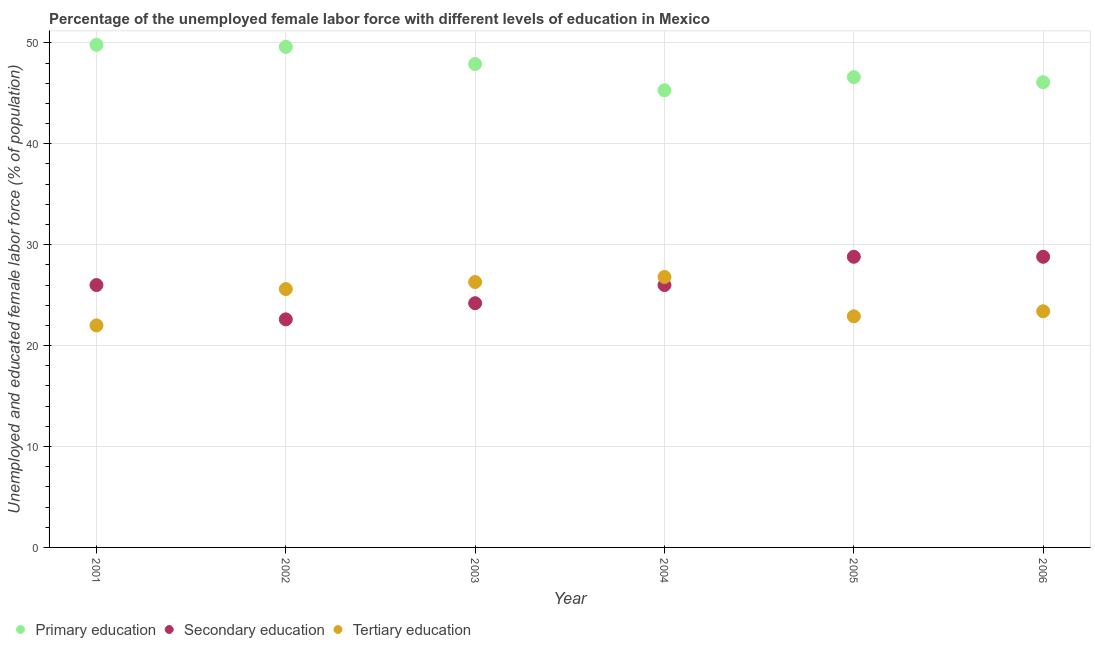What is the percentage of female labor force who received tertiary education in 2005?
Provide a succinct answer. 22.9. Across all years, what is the maximum percentage of female labor force who received secondary education?
Offer a very short reply. 28.8. In which year was the percentage of female labor force who received primary education minimum?
Give a very brief answer. 2004. What is the total percentage of female labor force who received primary education in the graph?
Ensure brevity in your answer.  285.3. What is the difference between the percentage of female labor force who received tertiary education in 2003 and that in 2005?
Your answer should be very brief. 3.4. What is the difference between the percentage of female labor force who received primary education in 2003 and the percentage of female labor force who received tertiary education in 2006?
Offer a terse response. 24.5. What is the average percentage of female labor force who received secondary education per year?
Keep it short and to the point. 26.07. In the year 2004, what is the difference between the percentage of female labor force who received primary education and percentage of female labor force who received secondary education?
Ensure brevity in your answer.  19.3. In how many years, is the percentage of female labor force who received tertiary education greater than 2 %?
Make the answer very short. 6. What is the ratio of the percentage of female labor force who received primary education in 2004 to that in 2005?
Offer a terse response. 0.97. Is the difference between the percentage of female labor force who received secondary education in 2003 and 2006 greater than the difference between the percentage of female labor force who received primary education in 2003 and 2006?
Your answer should be very brief. No. What is the difference between the highest and the lowest percentage of female labor force who received tertiary education?
Ensure brevity in your answer.  4.8. In how many years, is the percentage of female labor force who received secondary education greater than the average percentage of female labor force who received secondary education taken over all years?
Provide a succinct answer. 2. Is the sum of the percentage of female labor force who received tertiary education in 2003 and 2005 greater than the maximum percentage of female labor force who received primary education across all years?
Give a very brief answer. No. Is it the case that in every year, the sum of the percentage of female labor force who received primary education and percentage of female labor force who received secondary education is greater than the percentage of female labor force who received tertiary education?
Provide a short and direct response. Yes. How many dotlines are there?
Keep it short and to the point. 3. How many years are there in the graph?
Your answer should be very brief. 6. Where does the legend appear in the graph?
Offer a terse response. Bottom left. How are the legend labels stacked?
Offer a very short reply. Horizontal. What is the title of the graph?
Your response must be concise. Percentage of the unemployed female labor force with different levels of education in Mexico. Does "Primary" appear as one of the legend labels in the graph?
Your response must be concise. No. What is the label or title of the Y-axis?
Your response must be concise. Unemployed and educated female labor force (% of population). What is the Unemployed and educated female labor force (% of population) of Primary education in 2001?
Give a very brief answer. 49.8. What is the Unemployed and educated female labor force (% of population) of Secondary education in 2001?
Your response must be concise. 26. What is the Unemployed and educated female labor force (% of population) in Primary education in 2002?
Offer a very short reply. 49.6. What is the Unemployed and educated female labor force (% of population) of Secondary education in 2002?
Offer a terse response. 22.6. What is the Unemployed and educated female labor force (% of population) of Tertiary education in 2002?
Provide a succinct answer. 25.6. What is the Unemployed and educated female labor force (% of population) of Primary education in 2003?
Give a very brief answer. 47.9. What is the Unemployed and educated female labor force (% of population) in Secondary education in 2003?
Keep it short and to the point. 24.2. What is the Unemployed and educated female labor force (% of population) of Tertiary education in 2003?
Your answer should be compact. 26.3. What is the Unemployed and educated female labor force (% of population) in Primary education in 2004?
Provide a succinct answer. 45.3. What is the Unemployed and educated female labor force (% of population) of Tertiary education in 2004?
Offer a terse response. 26.8. What is the Unemployed and educated female labor force (% of population) of Primary education in 2005?
Provide a succinct answer. 46.6. What is the Unemployed and educated female labor force (% of population) in Secondary education in 2005?
Give a very brief answer. 28.8. What is the Unemployed and educated female labor force (% of population) in Tertiary education in 2005?
Offer a very short reply. 22.9. What is the Unemployed and educated female labor force (% of population) in Primary education in 2006?
Provide a short and direct response. 46.1. What is the Unemployed and educated female labor force (% of population) of Secondary education in 2006?
Your answer should be compact. 28.8. What is the Unemployed and educated female labor force (% of population) in Tertiary education in 2006?
Make the answer very short. 23.4. Across all years, what is the maximum Unemployed and educated female labor force (% of population) in Primary education?
Provide a short and direct response. 49.8. Across all years, what is the maximum Unemployed and educated female labor force (% of population) of Secondary education?
Make the answer very short. 28.8. Across all years, what is the maximum Unemployed and educated female labor force (% of population) in Tertiary education?
Offer a terse response. 26.8. Across all years, what is the minimum Unemployed and educated female labor force (% of population) of Primary education?
Offer a terse response. 45.3. Across all years, what is the minimum Unemployed and educated female labor force (% of population) of Secondary education?
Your answer should be compact. 22.6. What is the total Unemployed and educated female labor force (% of population) of Primary education in the graph?
Make the answer very short. 285.3. What is the total Unemployed and educated female labor force (% of population) of Secondary education in the graph?
Provide a short and direct response. 156.4. What is the total Unemployed and educated female labor force (% of population) of Tertiary education in the graph?
Make the answer very short. 147. What is the difference between the Unemployed and educated female labor force (% of population) of Secondary education in 2001 and that in 2002?
Offer a terse response. 3.4. What is the difference between the Unemployed and educated female labor force (% of population) of Primary education in 2001 and that in 2003?
Provide a succinct answer. 1.9. What is the difference between the Unemployed and educated female labor force (% of population) in Secondary education in 2001 and that in 2003?
Ensure brevity in your answer.  1.8. What is the difference between the Unemployed and educated female labor force (% of population) of Tertiary education in 2001 and that in 2003?
Your answer should be very brief. -4.3. What is the difference between the Unemployed and educated female labor force (% of population) of Primary education in 2001 and that in 2004?
Provide a short and direct response. 4.5. What is the difference between the Unemployed and educated female labor force (% of population) of Secondary education in 2001 and that in 2004?
Make the answer very short. 0. What is the difference between the Unemployed and educated female labor force (% of population) of Primary education in 2001 and that in 2005?
Your answer should be very brief. 3.2. What is the difference between the Unemployed and educated female labor force (% of population) in Secondary education in 2001 and that in 2005?
Offer a very short reply. -2.8. What is the difference between the Unemployed and educated female labor force (% of population) of Secondary education in 2001 and that in 2006?
Provide a succinct answer. -2.8. What is the difference between the Unemployed and educated female labor force (% of population) of Tertiary education in 2001 and that in 2006?
Your response must be concise. -1.4. What is the difference between the Unemployed and educated female labor force (% of population) in Primary education in 2002 and that in 2004?
Your answer should be very brief. 4.3. What is the difference between the Unemployed and educated female labor force (% of population) in Secondary education in 2002 and that in 2004?
Offer a very short reply. -3.4. What is the difference between the Unemployed and educated female labor force (% of population) in Tertiary education in 2002 and that in 2004?
Make the answer very short. -1.2. What is the difference between the Unemployed and educated female labor force (% of population) in Primary education in 2002 and that in 2005?
Keep it short and to the point. 3. What is the difference between the Unemployed and educated female labor force (% of population) of Tertiary education in 2002 and that in 2005?
Your answer should be very brief. 2.7. What is the difference between the Unemployed and educated female labor force (% of population) in Primary education in 2003 and that in 2004?
Provide a short and direct response. 2.6. What is the difference between the Unemployed and educated female labor force (% of population) of Primary education in 2003 and that in 2005?
Offer a terse response. 1.3. What is the difference between the Unemployed and educated female labor force (% of population) in Secondary education in 2003 and that in 2005?
Keep it short and to the point. -4.6. What is the difference between the Unemployed and educated female labor force (% of population) in Tertiary education in 2003 and that in 2005?
Your answer should be very brief. 3.4. What is the difference between the Unemployed and educated female labor force (% of population) in Secondary education in 2003 and that in 2006?
Give a very brief answer. -4.6. What is the difference between the Unemployed and educated female labor force (% of population) of Primary education in 2004 and that in 2006?
Keep it short and to the point. -0.8. What is the difference between the Unemployed and educated female labor force (% of population) in Tertiary education in 2004 and that in 2006?
Your response must be concise. 3.4. What is the difference between the Unemployed and educated female labor force (% of population) of Secondary education in 2005 and that in 2006?
Your answer should be very brief. 0. What is the difference between the Unemployed and educated female labor force (% of population) of Tertiary education in 2005 and that in 2006?
Your response must be concise. -0.5. What is the difference between the Unemployed and educated female labor force (% of population) of Primary education in 2001 and the Unemployed and educated female labor force (% of population) of Secondary education in 2002?
Give a very brief answer. 27.2. What is the difference between the Unemployed and educated female labor force (% of population) in Primary education in 2001 and the Unemployed and educated female labor force (% of population) in Tertiary education in 2002?
Your answer should be compact. 24.2. What is the difference between the Unemployed and educated female labor force (% of population) in Primary education in 2001 and the Unemployed and educated female labor force (% of population) in Secondary education in 2003?
Provide a succinct answer. 25.6. What is the difference between the Unemployed and educated female labor force (% of population) of Primary education in 2001 and the Unemployed and educated female labor force (% of population) of Secondary education in 2004?
Give a very brief answer. 23.8. What is the difference between the Unemployed and educated female labor force (% of population) in Secondary education in 2001 and the Unemployed and educated female labor force (% of population) in Tertiary education in 2004?
Your answer should be compact. -0.8. What is the difference between the Unemployed and educated female labor force (% of population) in Primary education in 2001 and the Unemployed and educated female labor force (% of population) in Tertiary education in 2005?
Ensure brevity in your answer.  26.9. What is the difference between the Unemployed and educated female labor force (% of population) in Primary education in 2001 and the Unemployed and educated female labor force (% of population) in Secondary education in 2006?
Ensure brevity in your answer.  21. What is the difference between the Unemployed and educated female labor force (% of population) of Primary education in 2001 and the Unemployed and educated female labor force (% of population) of Tertiary education in 2006?
Offer a terse response. 26.4. What is the difference between the Unemployed and educated female labor force (% of population) of Primary education in 2002 and the Unemployed and educated female labor force (% of population) of Secondary education in 2003?
Your answer should be very brief. 25.4. What is the difference between the Unemployed and educated female labor force (% of population) in Primary education in 2002 and the Unemployed and educated female labor force (% of population) in Tertiary education in 2003?
Your answer should be very brief. 23.3. What is the difference between the Unemployed and educated female labor force (% of population) of Primary education in 2002 and the Unemployed and educated female labor force (% of population) of Secondary education in 2004?
Your answer should be very brief. 23.6. What is the difference between the Unemployed and educated female labor force (% of population) in Primary education in 2002 and the Unemployed and educated female labor force (% of population) in Tertiary education in 2004?
Offer a terse response. 22.8. What is the difference between the Unemployed and educated female labor force (% of population) in Primary education in 2002 and the Unemployed and educated female labor force (% of population) in Secondary education in 2005?
Your answer should be very brief. 20.8. What is the difference between the Unemployed and educated female labor force (% of population) of Primary education in 2002 and the Unemployed and educated female labor force (% of population) of Tertiary education in 2005?
Give a very brief answer. 26.7. What is the difference between the Unemployed and educated female labor force (% of population) of Primary education in 2002 and the Unemployed and educated female labor force (% of population) of Secondary education in 2006?
Give a very brief answer. 20.8. What is the difference between the Unemployed and educated female labor force (% of population) in Primary education in 2002 and the Unemployed and educated female labor force (% of population) in Tertiary education in 2006?
Offer a very short reply. 26.2. What is the difference between the Unemployed and educated female labor force (% of population) of Primary education in 2003 and the Unemployed and educated female labor force (% of population) of Secondary education in 2004?
Provide a short and direct response. 21.9. What is the difference between the Unemployed and educated female labor force (% of population) of Primary education in 2003 and the Unemployed and educated female labor force (% of population) of Tertiary education in 2004?
Offer a very short reply. 21.1. What is the difference between the Unemployed and educated female labor force (% of population) in Primary education in 2003 and the Unemployed and educated female labor force (% of population) in Tertiary education in 2005?
Provide a succinct answer. 25. What is the difference between the Unemployed and educated female labor force (% of population) of Secondary education in 2003 and the Unemployed and educated female labor force (% of population) of Tertiary education in 2005?
Give a very brief answer. 1.3. What is the difference between the Unemployed and educated female labor force (% of population) of Primary education in 2003 and the Unemployed and educated female labor force (% of population) of Secondary education in 2006?
Keep it short and to the point. 19.1. What is the difference between the Unemployed and educated female labor force (% of population) of Secondary education in 2003 and the Unemployed and educated female labor force (% of population) of Tertiary education in 2006?
Offer a very short reply. 0.8. What is the difference between the Unemployed and educated female labor force (% of population) in Primary education in 2004 and the Unemployed and educated female labor force (% of population) in Secondary education in 2005?
Your answer should be compact. 16.5. What is the difference between the Unemployed and educated female labor force (% of population) of Primary education in 2004 and the Unemployed and educated female labor force (% of population) of Tertiary education in 2005?
Your response must be concise. 22.4. What is the difference between the Unemployed and educated female labor force (% of population) of Secondary education in 2004 and the Unemployed and educated female labor force (% of population) of Tertiary education in 2005?
Ensure brevity in your answer.  3.1. What is the difference between the Unemployed and educated female labor force (% of population) of Primary education in 2004 and the Unemployed and educated female labor force (% of population) of Secondary education in 2006?
Your response must be concise. 16.5. What is the difference between the Unemployed and educated female labor force (% of population) in Primary education in 2004 and the Unemployed and educated female labor force (% of population) in Tertiary education in 2006?
Your answer should be compact. 21.9. What is the difference between the Unemployed and educated female labor force (% of population) in Secondary education in 2004 and the Unemployed and educated female labor force (% of population) in Tertiary education in 2006?
Offer a very short reply. 2.6. What is the difference between the Unemployed and educated female labor force (% of population) in Primary education in 2005 and the Unemployed and educated female labor force (% of population) in Tertiary education in 2006?
Make the answer very short. 23.2. What is the average Unemployed and educated female labor force (% of population) in Primary education per year?
Your answer should be very brief. 47.55. What is the average Unemployed and educated female labor force (% of population) in Secondary education per year?
Ensure brevity in your answer.  26.07. In the year 2001, what is the difference between the Unemployed and educated female labor force (% of population) of Primary education and Unemployed and educated female labor force (% of population) of Secondary education?
Make the answer very short. 23.8. In the year 2001, what is the difference between the Unemployed and educated female labor force (% of population) of Primary education and Unemployed and educated female labor force (% of population) of Tertiary education?
Provide a succinct answer. 27.8. In the year 2002, what is the difference between the Unemployed and educated female labor force (% of population) of Primary education and Unemployed and educated female labor force (% of population) of Secondary education?
Give a very brief answer. 27. In the year 2003, what is the difference between the Unemployed and educated female labor force (% of population) in Primary education and Unemployed and educated female labor force (% of population) in Secondary education?
Your answer should be compact. 23.7. In the year 2003, what is the difference between the Unemployed and educated female labor force (% of population) of Primary education and Unemployed and educated female labor force (% of population) of Tertiary education?
Provide a succinct answer. 21.6. In the year 2004, what is the difference between the Unemployed and educated female labor force (% of population) of Primary education and Unemployed and educated female labor force (% of population) of Secondary education?
Your answer should be very brief. 19.3. In the year 2004, what is the difference between the Unemployed and educated female labor force (% of population) of Primary education and Unemployed and educated female labor force (% of population) of Tertiary education?
Your answer should be very brief. 18.5. In the year 2005, what is the difference between the Unemployed and educated female labor force (% of population) in Primary education and Unemployed and educated female labor force (% of population) in Secondary education?
Give a very brief answer. 17.8. In the year 2005, what is the difference between the Unemployed and educated female labor force (% of population) of Primary education and Unemployed and educated female labor force (% of population) of Tertiary education?
Offer a terse response. 23.7. In the year 2005, what is the difference between the Unemployed and educated female labor force (% of population) in Secondary education and Unemployed and educated female labor force (% of population) in Tertiary education?
Provide a succinct answer. 5.9. In the year 2006, what is the difference between the Unemployed and educated female labor force (% of population) of Primary education and Unemployed and educated female labor force (% of population) of Tertiary education?
Offer a very short reply. 22.7. In the year 2006, what is the difference between the Unemployed and educated female labor force (% of population) in Secondary education and Unemployed and educated female labor force (% of population) in Tertiary education?
Provide a succinct answer. 5.4. What is the ratio of the Unemployed and educated female labor force (% of population) of Primary education in 2001 to that in 2002?
Your answer should be compact. 1. What is the ratio of the Unemployed and educated female labor force (% of population) of Secondary education in 2001 to that in 2002?
Keep it short and to the point. 1.15. What is the ratio of the Unemployed and educated female labor force (% of population) of Tertiary education in 2001 to that in 2002?
Keep it short and to the point. 0.86. What is the ratio of the Unemployed and educated female labor force (% of population) of Primary education in 2001 to that in 2003?
Provide a succinct answer. 1.04. What is the ratio of the Unemployed and educated female labor force (% of population) of Secondary education in 2001 to that in 2003?
Give a very brief answer. 1.07. What is the ratio of the Unemployed and educated female labor force (% of population) of Tertiary education in 2001 to that in 2003?
Make the answer very short. 0.84. What is the ratio of the Unemployed and educated female labor force (% of population) of Primary education in 2001 to that in 2004?
Your answer should be very brief. 1.1. What is the ratio of the Unemployed and educated female labor force (% of population) in Tertiary education in 2001 to that in 2004?
Your response must be concise. 0.82. What is the ratio of the Unemployed and educated female labor force (% of population) of Primary education in 2001 to that in 2005?
Your answer should be compact. 1.07. What is the ratio of the Unemployed and educated female labor force (% of population) of Secondary education in 2001 to that in 2005?
Keep it short and to the point. 0.9. What is the ratio of the Unemployed and educated female labor force (% of population) of Tertiary education in 2001 to that in 2005?
Offer a terse response. 0.96. What is the ratio of the Unemployed and educated female labor force (% of population) in Primary education in 2001 to that in 2006?
Keep it short and to the point. 1.08. What is the ratio of the Unemployed and educated female labor force (% of population) in Secondary education in 2001 to that in 2006?
Your answer should be compact. 0.9. What is the ratio of the Unemployed and educated female labor force (% of population) of Tertiary education in 2001 to that in 2006?
Offer a very short reply. 0.94. What is the ratio of the Unemployed and educated female labor force (% of population) of Primary education in 2002 to that in 2003?
Give a very brief answer. 1.04. What is the ratio of the Unemployed and educated female labor force (% of population) of Secondary education in 2002 to that in 2003?
Provide a short and direct response. 0.93. What is the ratio of the Unemployed and educated female labor force (% of population) of Tertiary education in 2002 to that in 2003?
Your response must be concise. 0.97. What is the ratio of the Unemployed and educated female labor force (% of population) in Primary education in 2002 to that in 2004?
Provide a succinct answer. 1.09. What is the ratio of the Unemployed and educated female labor force (% of population) of Secondary education in 2002 to that in 2004?
Provide a succinct answer. 0.87. What is the ratio of the Unemployed and educated female labor force (% of population) of Tertiary education in 2002 to that in 2004?
Ensure brevity in your answer.  0.96. What is the ratio of the Unemployed and educated female labor force (% of population) of Primary education in 2002 to that in 2005?
Your answer should be very brief. 1.06. What is the ratio of the Unemployed and educated female labor force (% of population) in Secondary education in 2002 to that in 2005?
Give a very brief answer. 0.78. What is the ratio of the Unemployed and educated female labor force (% of population) in Tertiary education in 2002 to that in 2005?
Provide a short and direct response. 1.12. What is the ratio of the Unemployed and educated female labor force (% of population) of Primary education in 2002 to that in 2006?
Ensure brevity in your answer.  1.08. What is the ratio of the Unemployed and educated female labor force (% of population) of Secondary education in 2002 to that in 2006?
Offer a very short reply. 0.78. What is the ratio of the Unemployed and educated female labor force (% of population) of Tertiary education in 2002 to that in 2006?
Provide a succinct answer. 1.09. What is the ratio of the Unemployed and educated female labor force (% of population) in Primary education in 2003 to that in 2004?
Ensure brevity in your answer.  1.06. What is the ratio of the Unemployed and educated female labor force (% of population) in Secondary education in 2003 to that in 2004?
Your answer should be very brief. 0.93. What is the ratio of the Unemployed and educated female labor force (% of population) of Tertiary education in 2003 to that in 2004?
Ensure brevity in your answer.  0.98. What is the ratio of the Unemployed and educated female labor force (% of population) in Primary education in 2003 to that in 2005?
Your answer should be compact. 1.03. What is the ratio of the Unemployed and educated female labor force (% of population) of Secondary education in 2003 to that in 2005?
Keep it short and to the point. 0.84. What is the ratio of the Unemployed and educated female labor force (% of population) of Tertiary education in 2003 to that in 2005?
Provide a succinct answer. 1.15. What is the ratio of the Unemployed and educated female labor force (% of population) in Primary education in 2003 to that in 2006?
Your answer should be very brief. 1.04. What is the ratio of the Unemployed and educated female labor force (% of population) of Secondary education in 2003 to that in 2006?
Make the answer very short. 0.84. What is the ratio of the Unemployed and educated female labor force (% of population) in Tertiary education in 2003 to that in 2006?
Your answer should be compact. 1.12. What is the ratio of the Unemployed and educated female labor force (% of population) in Primary education in 2004 to that in 2005?
Your answer should be very brief. 0.97. What is the ratio of the Unemployed and educated female labor force (% of population) in Secondary education in 2004 to that in 2005?
Ensure brevity in your answer.  0.9. What is the ratio of the Unemployed and educated female labor force (% of population) of Tertiary education in 2004 to that in 2005?
Ensure brevity in your answer.  1.17. What is the ratio of the Unemployed and educated female labor force (% of population) of Primary education in 2004 to that in 2006?
Offer a very short reply. 0.98. What is the ratio of the Unemployed and educated female labor force (% of population) in Secondary education in 2004 to that in 2006?
Your answer should be very brief. 0.9. What is the ratio of the Unemployed and educated female labor force (% of population) of Tertiary education in 2004 to that in 2006?
Offer a very short reply. 1.15. What is the ratio of the Unemployed and educated female labor force (% of population) of Primary education in 2005 to that in 2006?
Provide a short and direct response. 1.01. What is the ratio of the Unemployed and educated female labor force (% of population) in Tertiary education in 2005 to that in 2006?
Provide a short and direct response. 0.98. What is the difference between the highest and the second highest Unemployed and educated female labor force (% of population) of Secondary education?
Your response must be concise. 0. What is the difference between the highest and the second highest Unemployed and educated female labor force (% of population) in Tertiary education?
Offer a very short reply. 0.5. What is the difference between the highest and the lowest Unemployed and educated female labor force (% of population) of Primary education?
Your answer should be compact. 4.5. What is the difference between the highest and the lowest Unemployed and educated female labor force (% of population) in Tertiary education?
Your response must be concise. 4.8. 